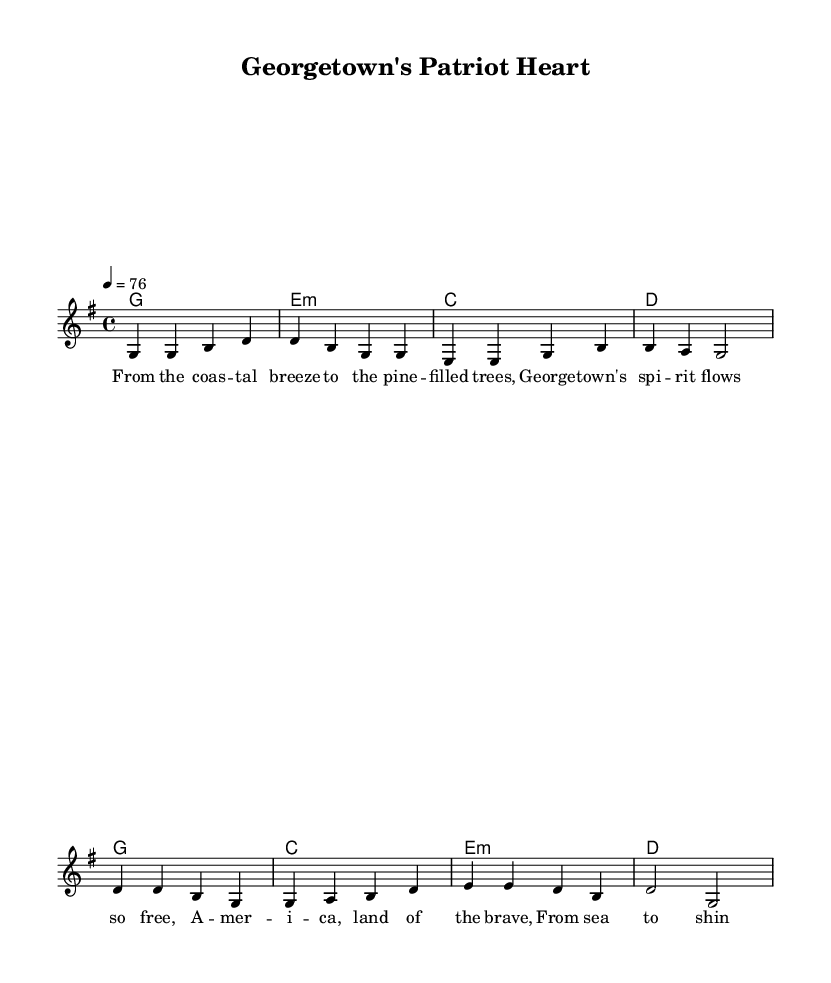What is the key signature of this music? The key signature is G major, which has one sharp (F#). This can be determined by looking at the "global" settings near the beginning of the code, where it is stated.
Answer: G major What is the time signature of the piece? The time signature is 4/4, as indicated in the "global" settings. This means there are four beats in each measure, and a quarter note gets one beat.
Answer: 4/4 What is the tempo marking for this piece? The tempo marking is 76 beats per minute. This is found in the "global" section, where it states \tempo 4 = 76. This indicates the speed at which the music should be played.
Answer: 76 How many measures are in the verse? There are four measures in the verse. This can be determined by counting the sets of musical notes in the section labeled as "Verse" within the melody part.
Answer: 4 What chords are used in the chorus? The chords used in the chorus are G, C, E minor, and D. This is derived from the "harmonies" section under the "Chorus" label, where each chord is specified for the respective measures.
Answer: G, C, E minor, D What thematic element is being celebrated in this ballad? The thematic element being celebrated is American heritage. This can be inferred from the lyrics provided in the "verseOne" section, which speaks to the spirit and land of America.
Answer: American heritage Why is the title significant to the content? The title "Georgetown's Patriot Heart" signifies a connection to patriotic themes. It suggests that the song is not only about a place but also about love and pride for American values, which aligns with the lyrical themes in the melody.
Answer: Patriotism 